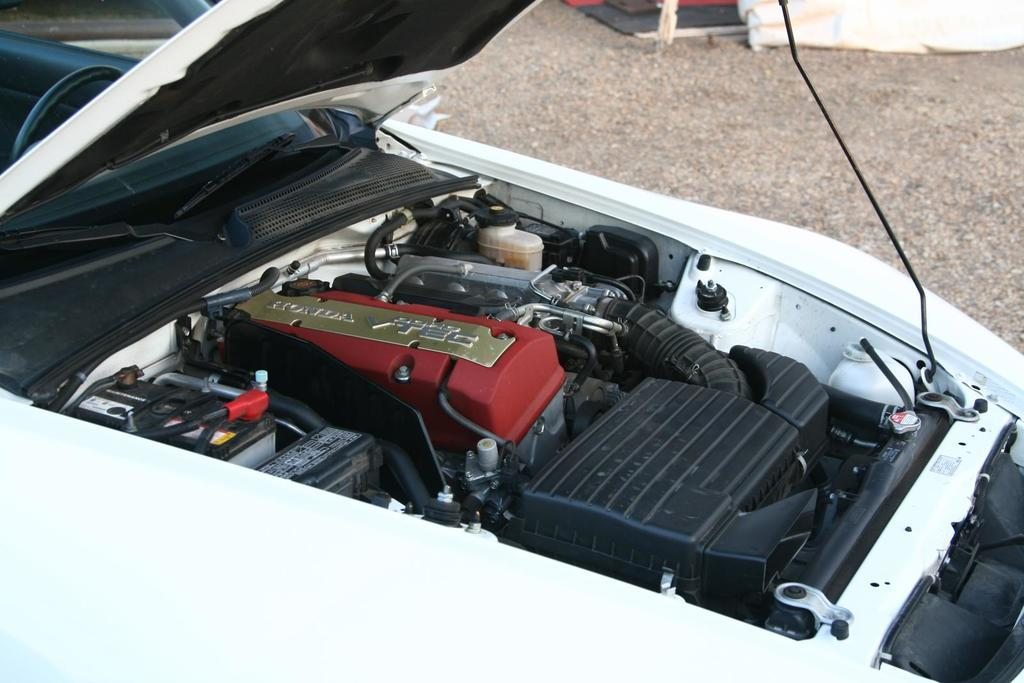What is the main subject in the foreground of the image? There is a vehicle in the foreground of the image. What part of the vehicle is visible in the image? The engine of the vehicle is visible. What can be seen in the background of the image? There is a walkway and objects visible in the background of the image. What type of wren can be seen sitting on the vehicle's engine in the image? There is no wren present in the image; the engine is visible, but no birds or animals are mentioned in the facts. 